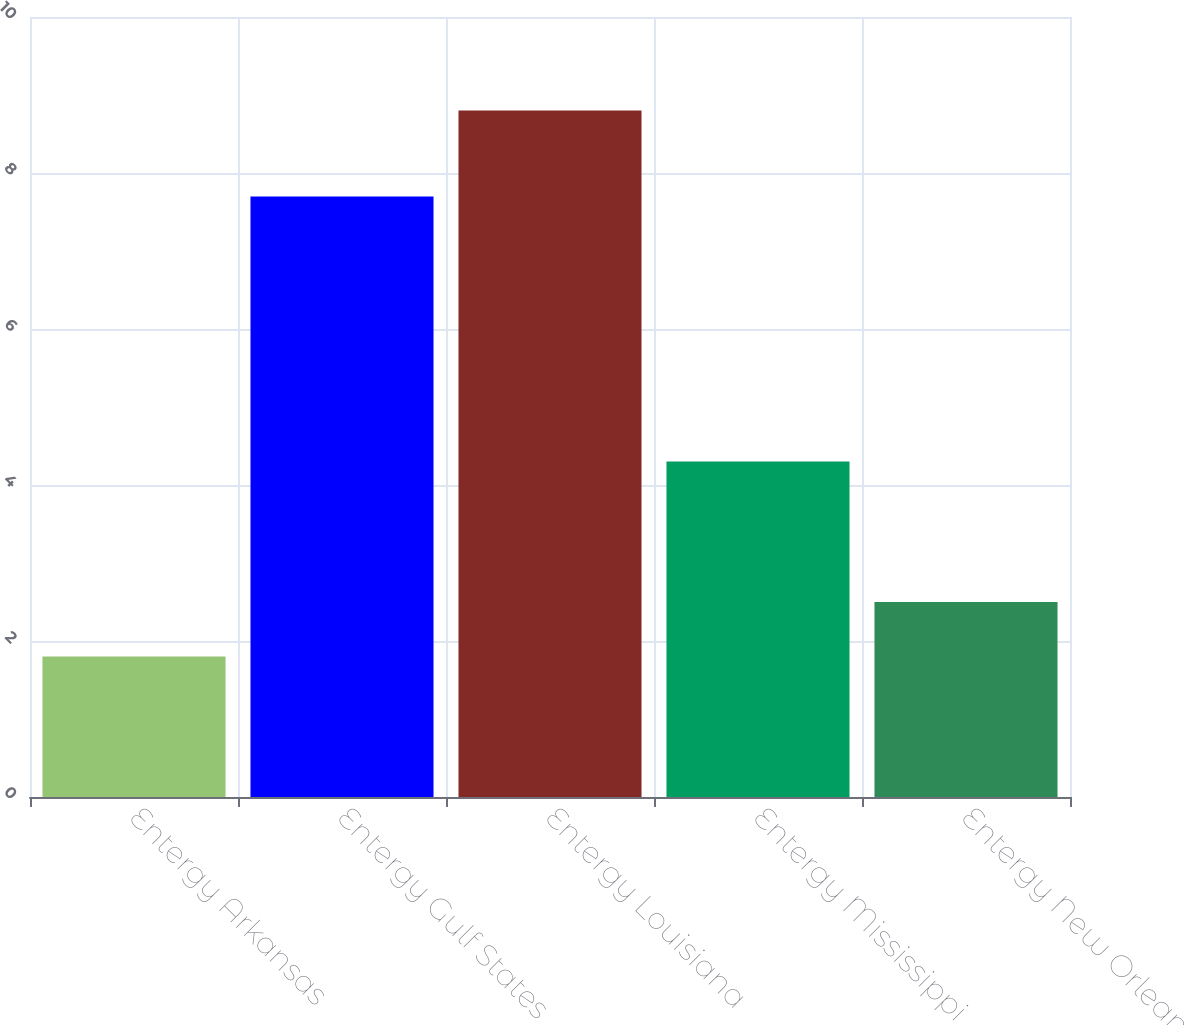Convert chart. <chart><loc_0><loc_0><loc_500><loc_500><bar_chart><fcel>Entergy Arkansas<fcel>Entergy Gulf States<fcel>Entergy Louisiana<fcel>Entergy Mississippi<fcel>Entergy New Orleans<nl><fcel>1.8<fcel>7.7<fcel>8.8<fcel>4.3<fcel>2.5<nl></chart> 